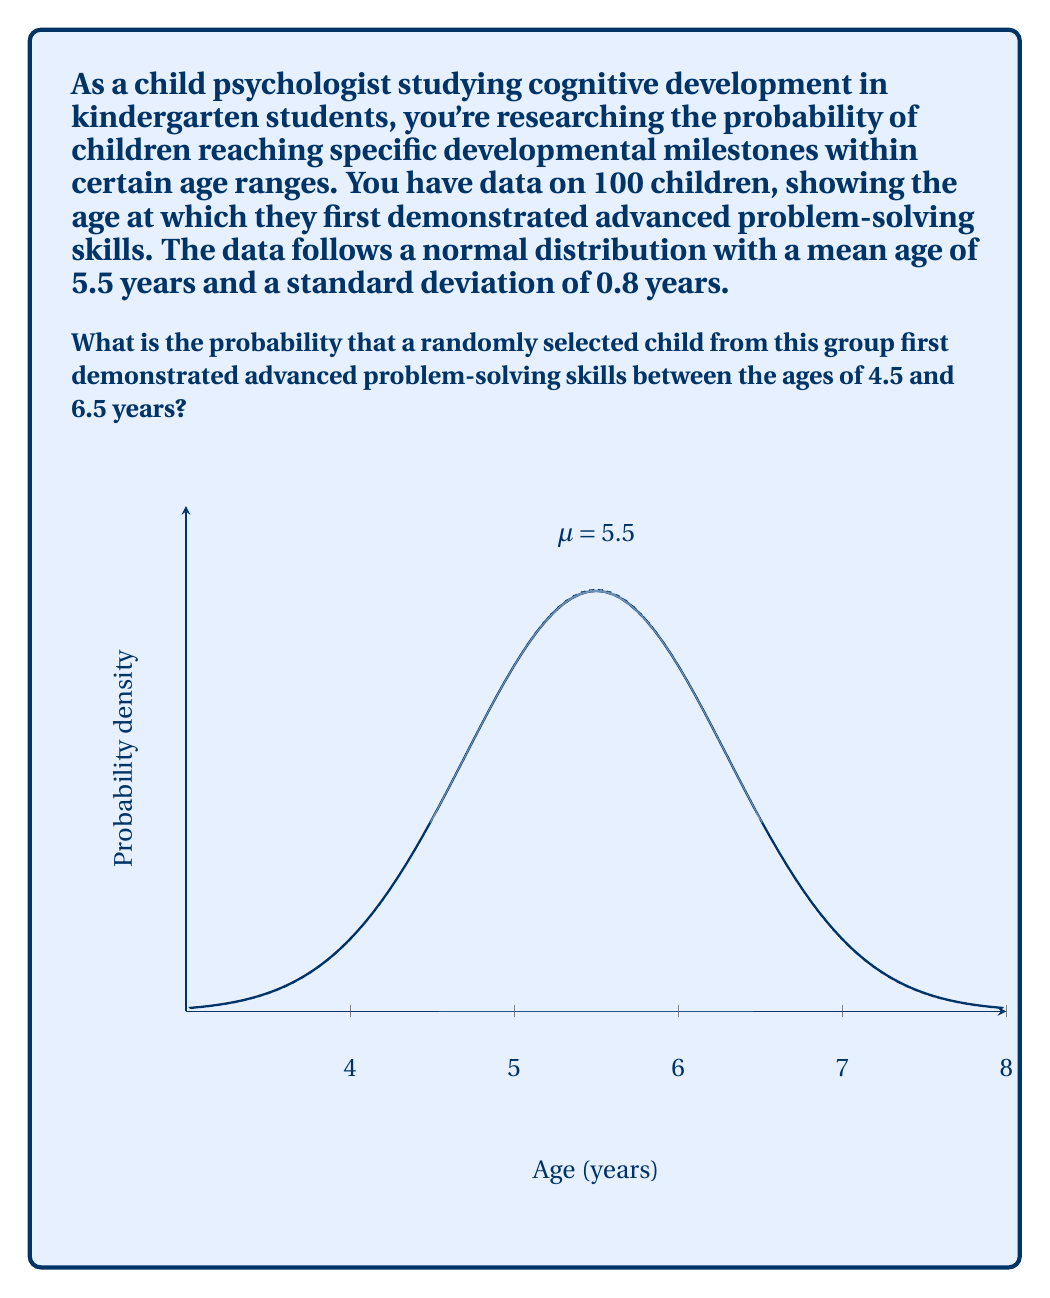Provide a solution to this math problem. To solve this problem, we'll use the properties of the normal distribution and the concept of z-scores. Here's a step-by-step approach:

1) We're given that the data follows a normal distribution with:
   Mean (μ) = 5.5 years
   Standard deviation (σ) = 0.8 years

2) We need to find the probability of a child's age falling between 4.5 and 6.5 years.

3) To use the standard normal distribution table, we need to convert these ages to z-scores:

   For 4.5 years: $z_1 = \frac{4.5 - 5.5}{0.8} = -1.25$
   For 6.5 years: $z_2 = \frac{6.5 - 5.5}{0.8} = 1.25$

4) Now, we need to find the area under the standard normal curve between z = -1.25 and z = 1.25.

5) Using a standard normal distribution table or calculator:
   P(z ≤ 1.25) = 0.8944
   P(z ≤ -1.25) = 1 - 0.8944 = 0.1056

6) The probability we're looking for is the difference between these two:
   P(-1.25 ≤ z ≤ 1.25) = 0.8944 - 0.1056 = 0.7888

7) Therefore, the probability that a randomly selected child first demonstrated advanced problem-solving skills between the ages of 4.5 and 6.5 years is approximately 0.7888 or 78.88%.
Answer: 0.7888 or 78.88% 